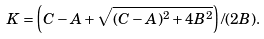<formula> <loc_0><loc_0><loc_500><loc_500>K = \left ( C - A + \sqrt { ( C - A ) ^ { 2 } + 4 B ^ { 2 } } \right ) / ( 2 B ) .</formula> 